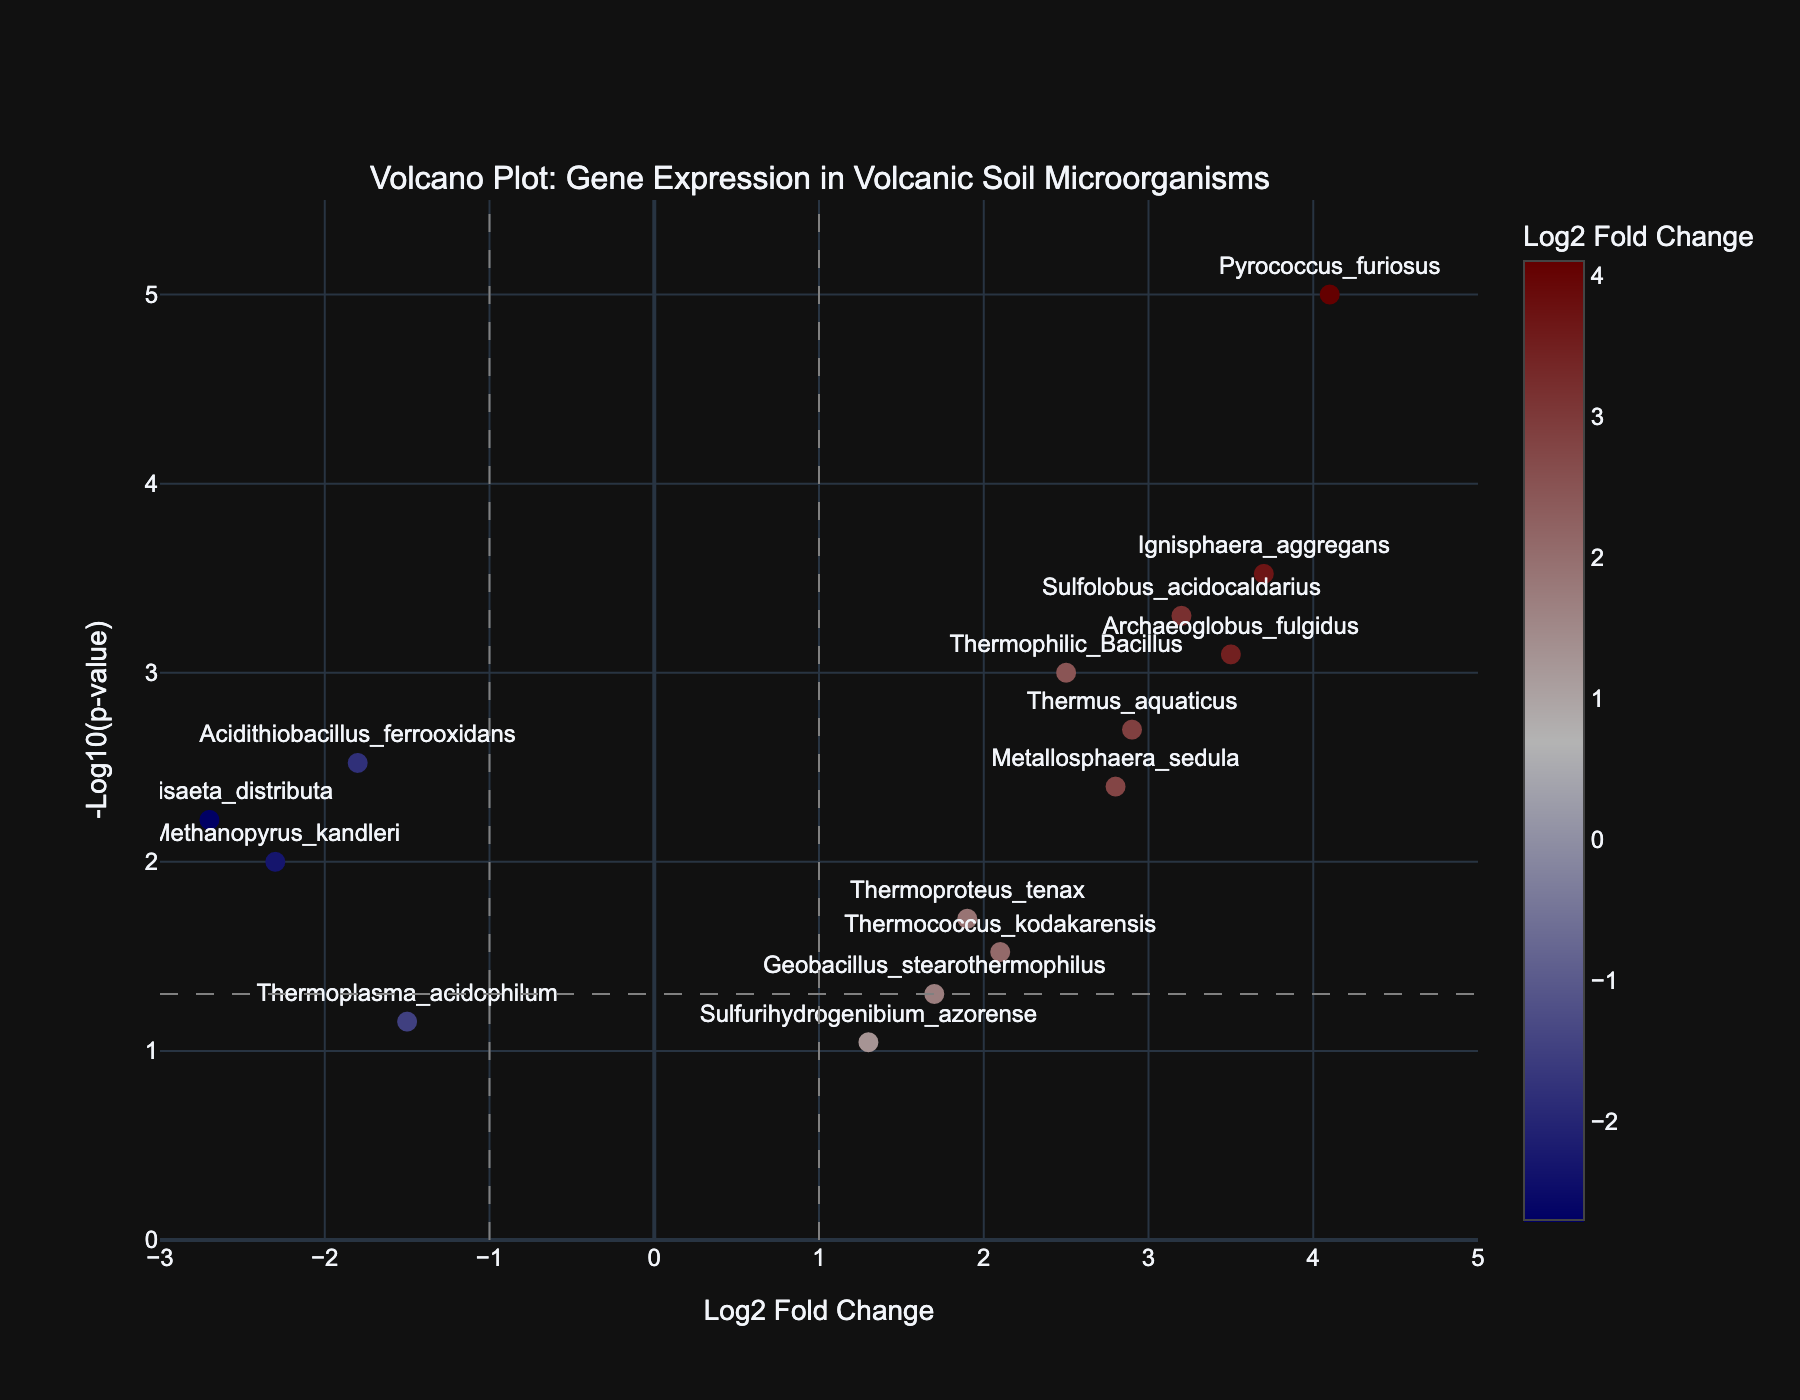What is the title of the Volcano Plot? The title of the Volcano Plot is typically displayed at the top of the figure. In this case, it reads "Volcano Plot: Gene Expression in Volcanic Soil Microorganisms".
Answer: Volcano Plot: Gene Expression in Volcanic Soil Microorganisms What does the x-axis represent? The x-axis represents the Log2 Fold Change of the genes, depicting the change in expression levels of the genes under varying temperature conditions.
Answer: Log2 Fold Change What does the y-axis represent? The y-axis represents the -Log10 of the p-value. This helps in visualizing how statistically significant the changes in gene expression are. Genes with lower p-values (higher -log10(p-values)) are more statistically significant.
Answer: -Log10(p-value) Which gene has the highest statistical significance? The statistical significance is indicated by the highest value on the y-axis (-Log10(p-value)). Pyrococcus_furiosus is the gene at the highest point on the y-axis, indicating it has the highest statistical significance.
Answer: Pyrococcus_furiosus Which genes have Log2 Fold Change greater than 3.5? To find these, look for points on the plot that are to the right of 3.5 on the x-axis. The corresponding text labels for these points are the genes: Pyrococcus_furiosus, Archaeoglobus_fulgidus, and Ignisphaera_aggregans.
Answer: Pyrococcus_furiosus, Archaeoglobus_fulgidus, Ignisphaera_aggregans What is the p-value threshold for significance in the plot, and which line represents it? Usually, a p-value of 0.05 is used as a threshold for significance. In the plot, the -Log10(0.05) is approximately 1.3. The horizontal dashed line at y=1.3 represents this p-value threshold.
Answer: 0.05, horizontal dashed line at y=1.3 Compare the Log2 Fold Change of Thermophilic Bacillus and Acidithiobacillus ferrooxidans. Which is higher? Thermophilic Bacillus has a Log2 Fold Change of 2.5, while Acidithiobacillus ferrooxidans has a Log2 Fold Change of -1.8. Since 2.5 is greater than -1.8, Thermophilic Bacillus has a higher Log2 Fold Change.
Answer: Thermophilic Bacillus Which gene has a p-value close to 0.002 but shows higher Log2 Fold Change than Thermus aquaticus? From the hover text, Thermus aquaticus has a p-value of 0.002 and a Log2 Fold Change of 2.9. The gene with a p-value close to 0.002 but higher Log2 Fold Change is Ignisphaera aggregans with a Log2 Fold Change of 3.7 and p-value 0.0003.
Answer: Ignisphaera aggregans How many genes show downregulation (negative Log2 Fold Change)? Genes with negative Log2 Fold Change are those on the left side of the y-axis (x < 0). These are: Acidithiobacillus ferrooxidans, Methanopyrus kandleri, Thermoplasma acidophilum, and Vulcanisaeta distributa, totaling 4 genes.
Answer: 4 